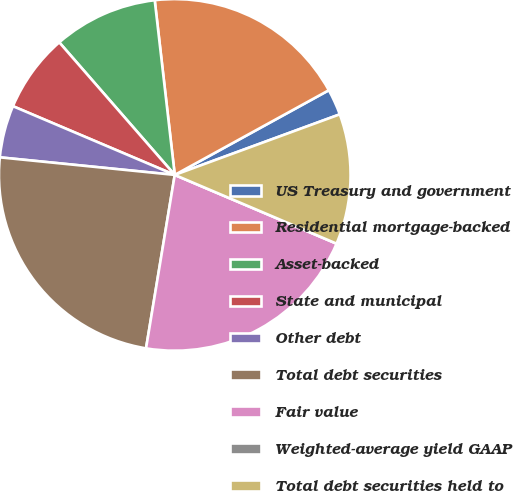<chart> <loc_0><loc_0><loc_500><loc_500><pie_chart><fcel>US Treasury and government<fcel>Residential mortgage-backed<fcel>Asset-backed<fcel>State and municipal<fcel>Other debt<fcel>Total debt securities<fcel>Fair value<fcel>Weighted-average yield GAAP<fcel>Total debt securities held to<nl><fcel>2.4%<fcel>18.82%<fcel>9.59%<fcel>7.2%<fcel>4.8%<fcel>23.98%<fcel>21.22%<fcel>0.0%<fcel>11.99%<nl></chart> 